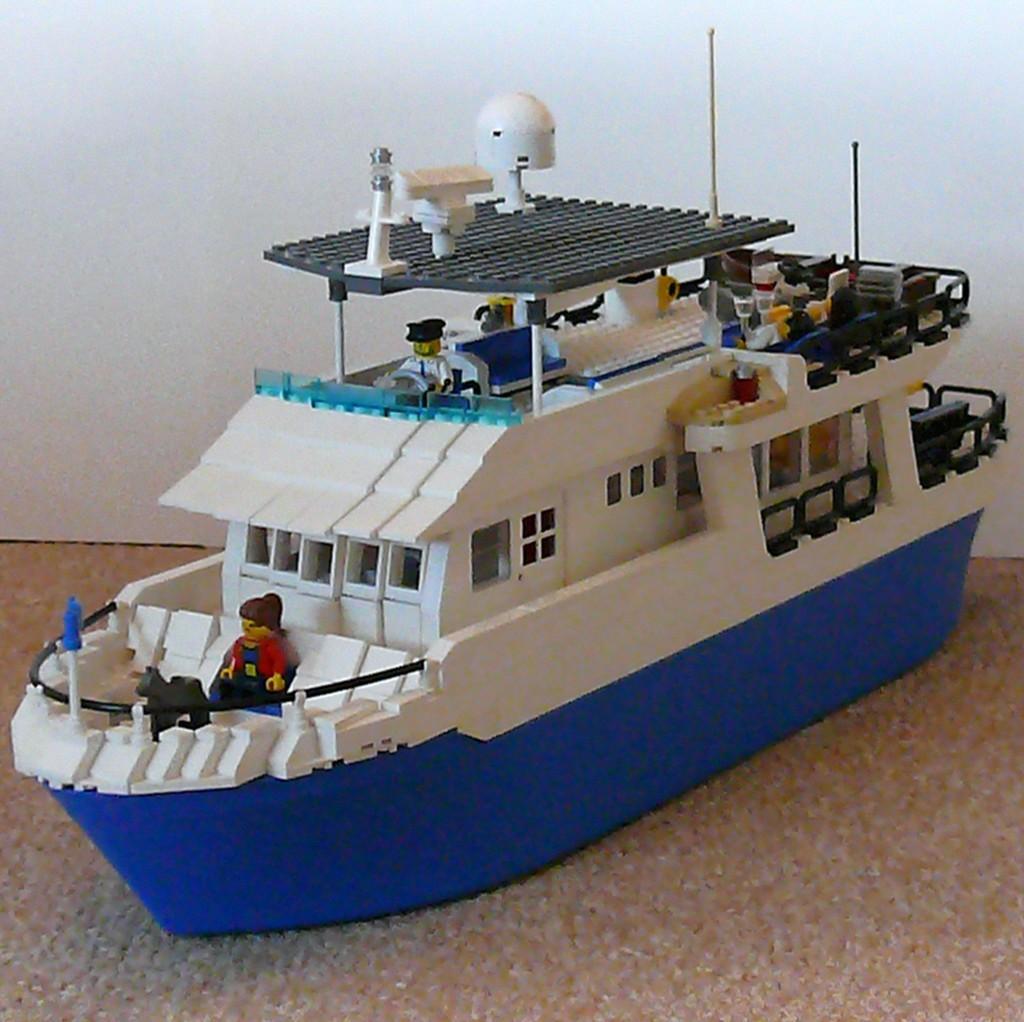How would you summarize this image in a sentence or two? In this image I can see a toy ship. In the background, I can see the wall. 